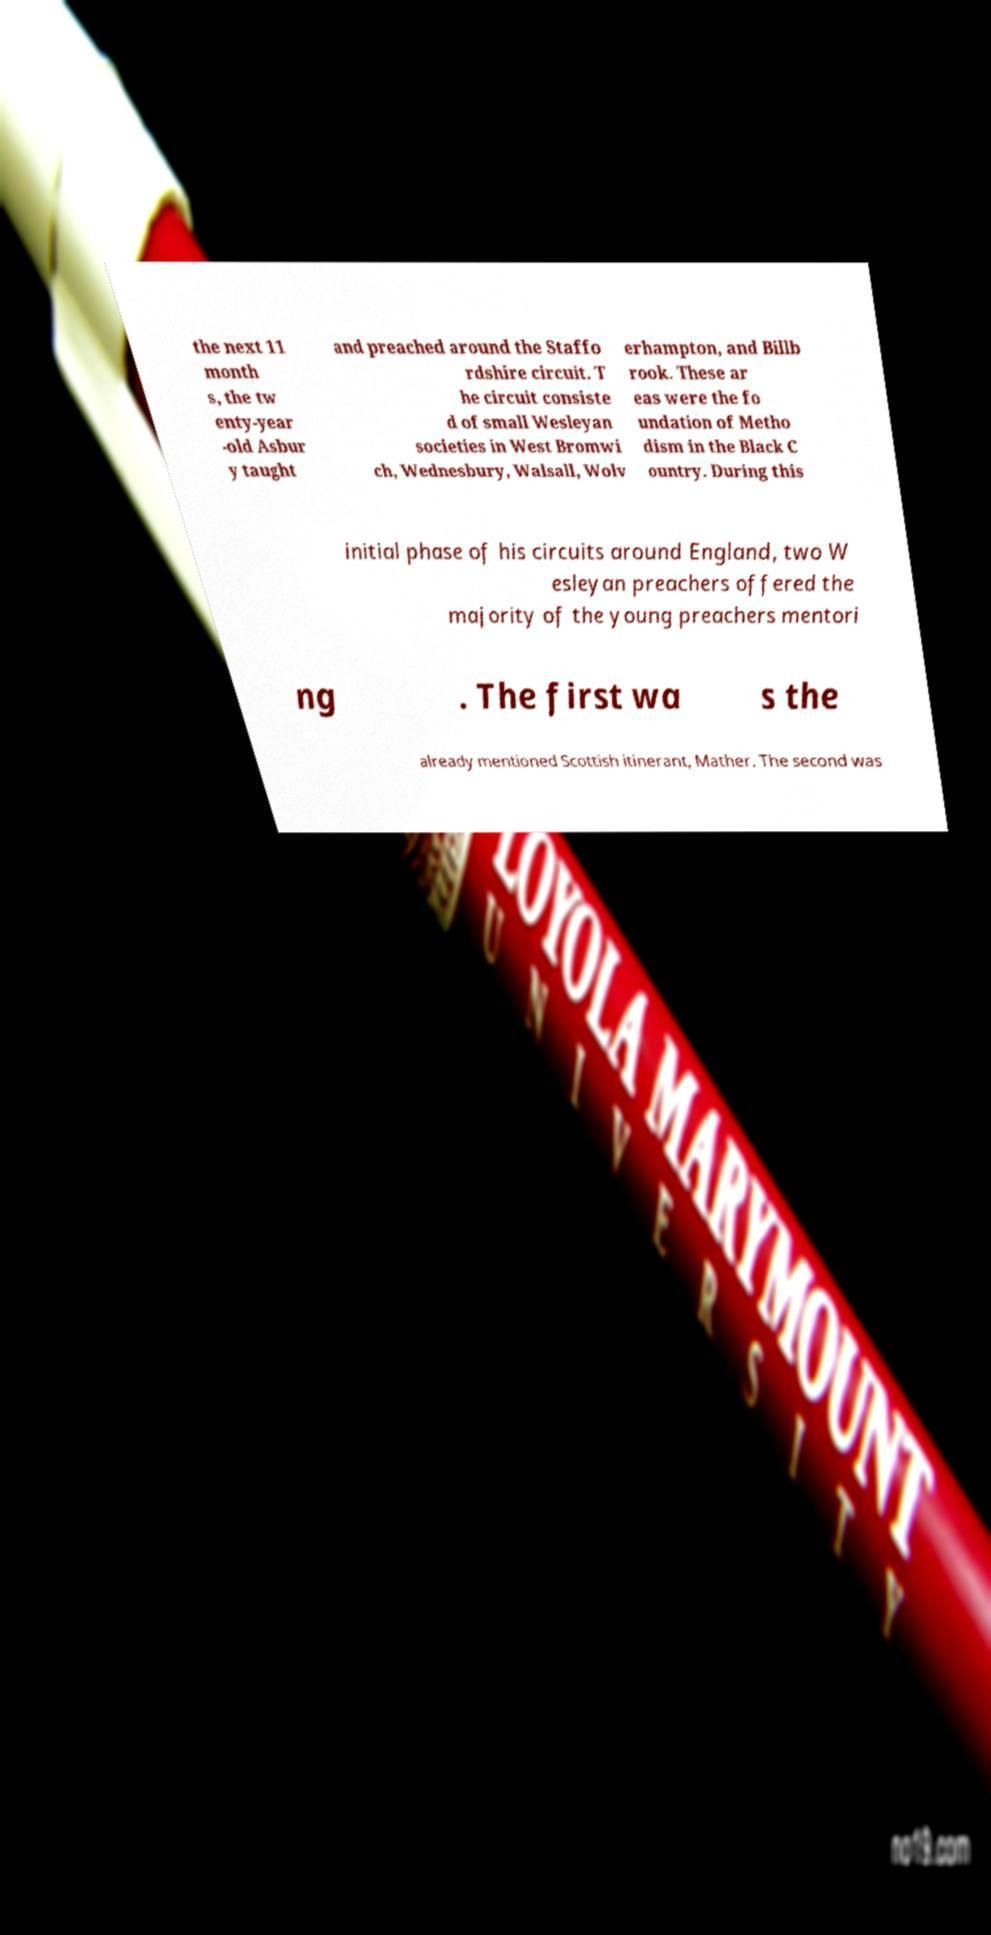I need the written content from this picture converted into text. Can you do that? the next 11 month s, the tw enty-year -old Asbur y taught and preached around the Staffo rdshire circuit. T he circuit consiste d of small Wesleyan societies in West Bromwi ch, Wednesbury, Walsall, Wolv erhampton, and Billb rook. These ar eas were the fo undation of Metho dism in the Black C ountry. During this initial phase of his circuits around England, two W esleyan preachers offered the majority of the young preachers mentori ng . The first wa s the already mentioned Scottish itinerant, Mather. The second was 